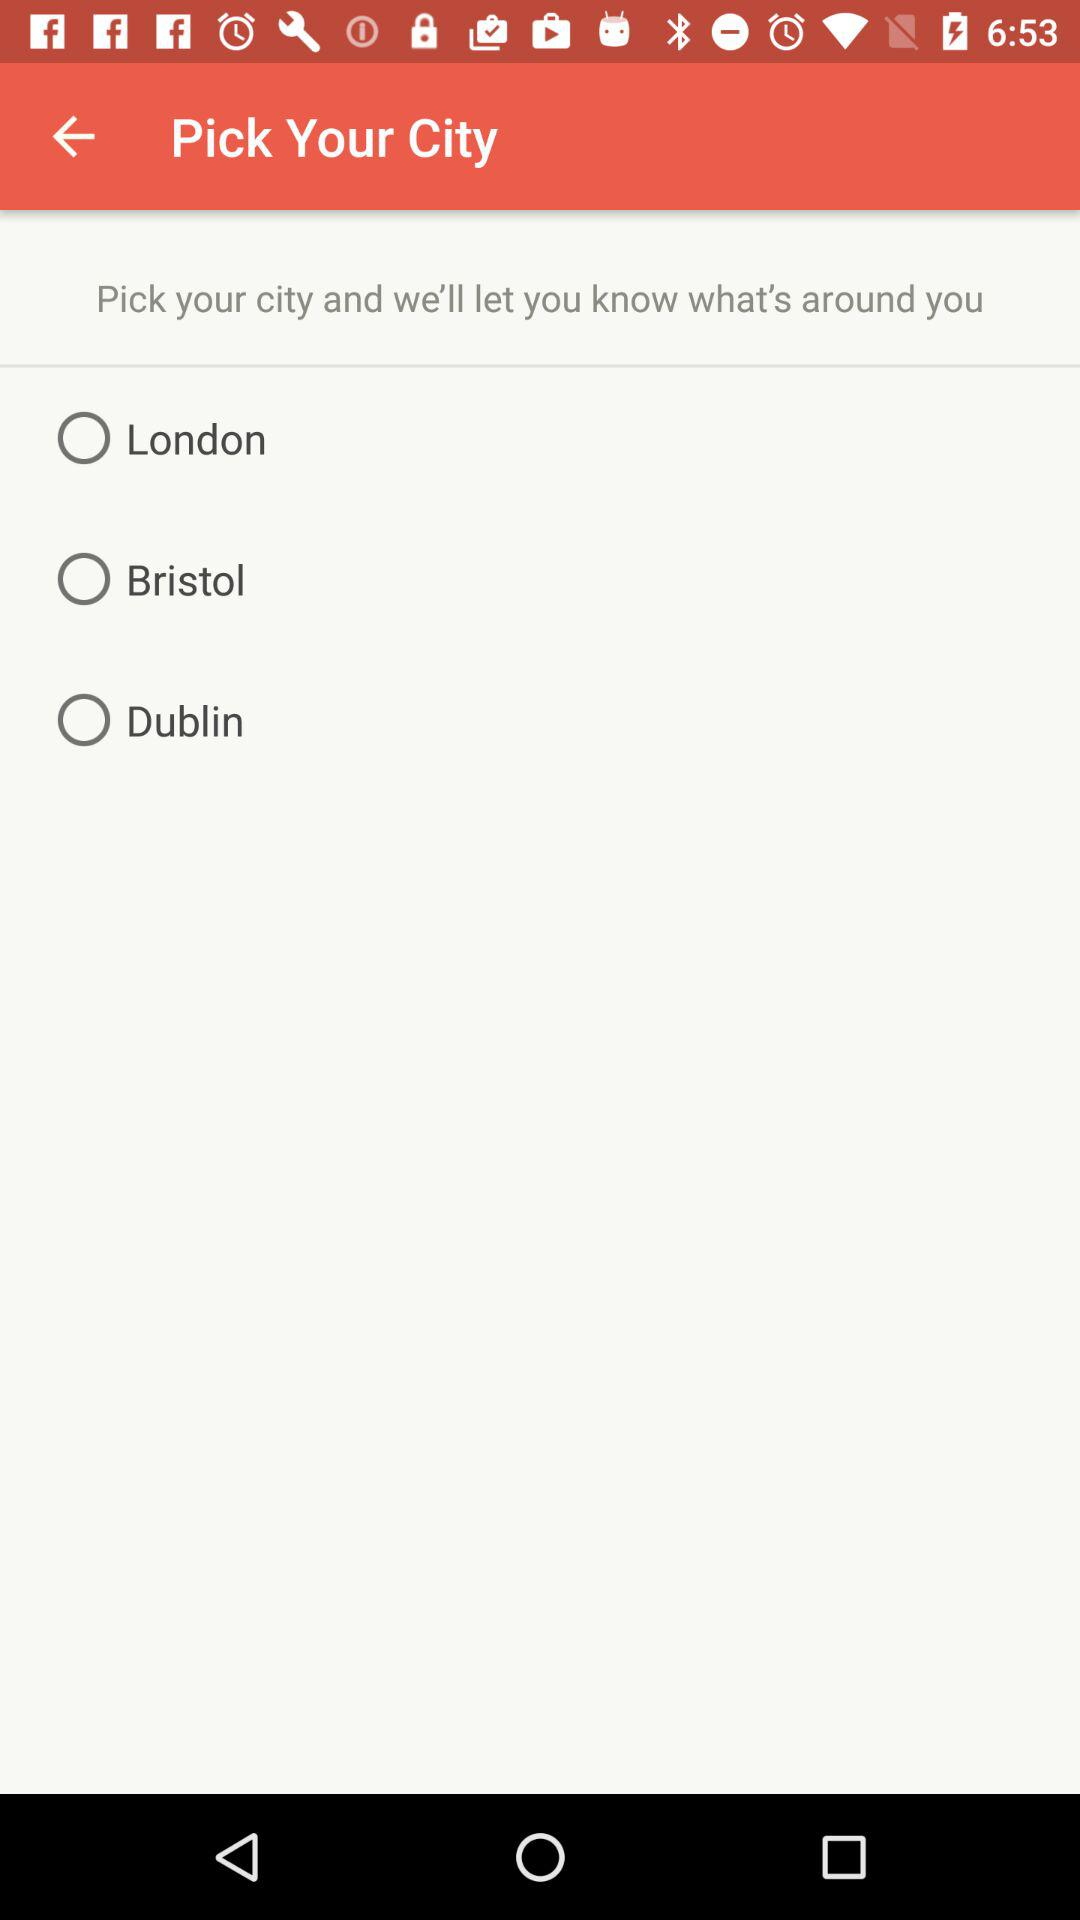How many cities can I choose from?
Answer the question using a single word or phrase. 3 